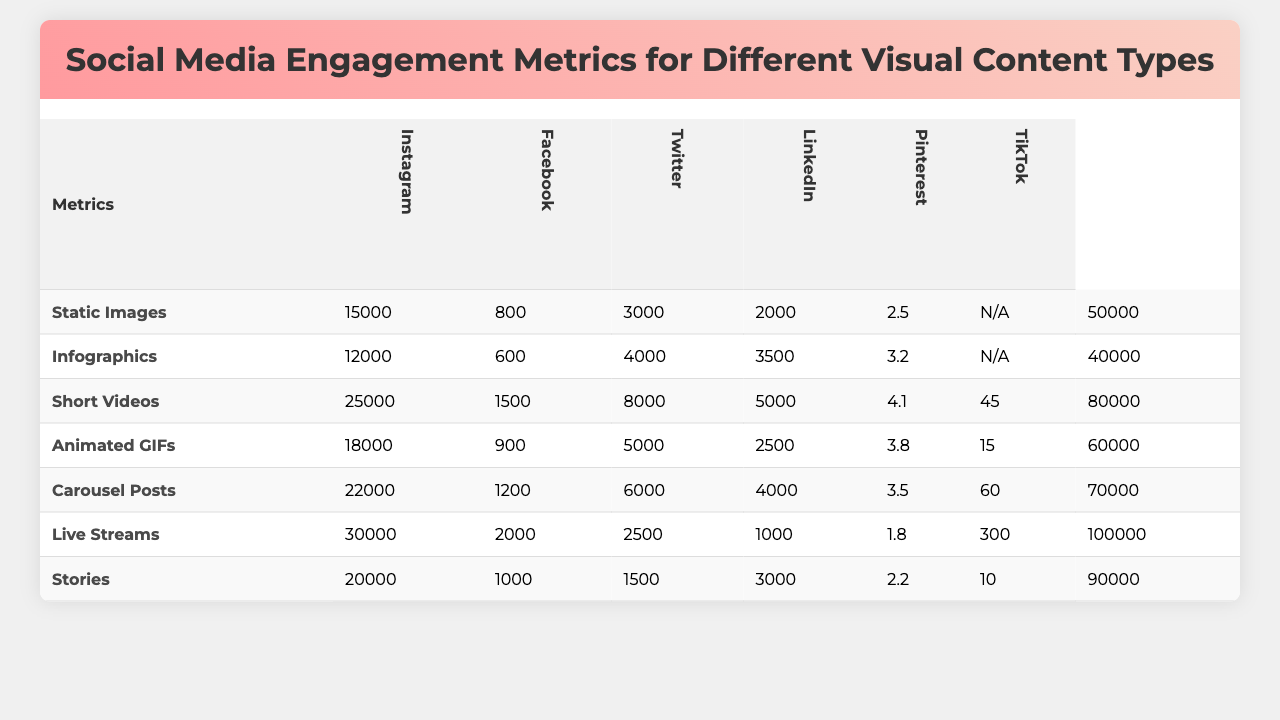What type of visual content received the most likes on Instagram? The table shows that "Carousel Posts" received the most likes on Instagram with a total of 22,000 likes.
Answer: Carousel Posts Which platform had the highest total impressions for animated GIFs? From the table, "TikTok" had the highest impressions for animated GIFs, totaling 100,000 impressions.
Answer: TikTok What is the average engagement rate for Short Videos across all platforms? To find the average engagement rate for Short Videos, we add the engagement rates from all platforms (5.5 + 3.8 + 3.2 + 4.2 + 3.5 + 3.0 + 3.0 = 23.2) and divide by 6. The average is 23.2 / 6 = 3.87.
Answer: 3.87 Did Stories have a higher click-through rate than Live Streams? The click-through rate for Stories is 2.2, while for Live Streams it is 1.8. Since 2.2 is greater than 1.8, the statement is true.
Answer: Yes Which content type had the highest number of saves across all platforms? By comparing the saves for each content type, "Short Videos" had the highest number of saves with 5000 saves.
Answer: Short Videos Calculate the total number of shares for Infographics and compare it to the total for Static Images. Which is greater? Total shares for Infographics is 4000 and for Static Images is 3000. Since 4000 is greater than 3000, Infographics have more shares.
Answer: Infographics What is the difference in comments between Carousel Posts and Static Images? The number of comments for Carousel Posts is 1200, and for Static Images, it is 800. The difference is 1200 - 800 = 400.
Answer: 400 What color scheme is associated with the highest average engagement rate? The table shows the average engagement rates, and "Vibrant Data Visualization" corresponds to the highest average engagement rate of 4.2.
Answer: Vibrant Data Visualization How many total likes were garnered by all the content types on Facebook? The total likes for Facebook are: (12,000 + 6,000 + 25,000 + 18,000 + 22,000 + 3,000 + 20,000) add up to 96,000 likes.
Answer: 96,000 Is the watch time for Carousel Posts greater than that for Animated GIFs? The table indicates that the watch time for Carousel Posts is 60 seconds, while for Animated GIFs it is 15 seconds. Since 60 is greater than 15, the statement is true.
Answer: Yes What is the best time to post for TikTok? The best time to post for TikTok according to the table is 8 PM.
Answer: 8 PM 